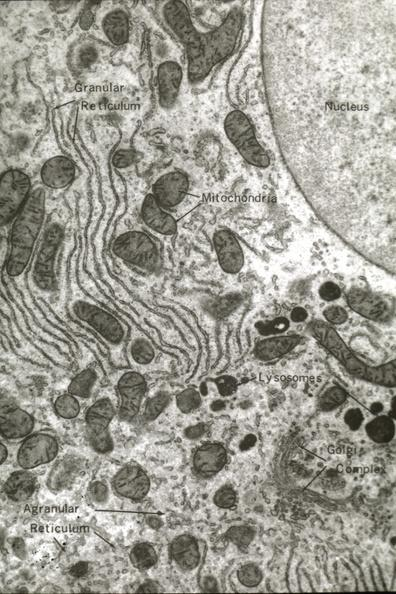s liver present?
Answer the question using a single word or phrase. Yes 